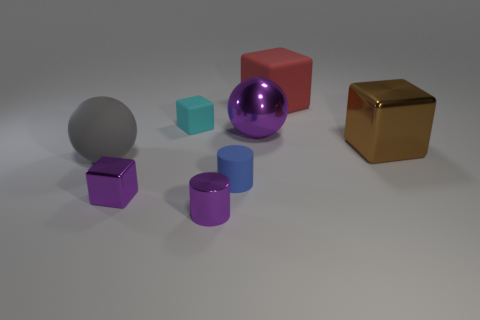Can you tell me about the colors and textures of the objects in the image? Certainly! There's a range of colors and textures here. Starting from the left, we have a gray matte sphere, a violet matte cube, a cyan matte cube, a reflective purple sphere, a deep blue glossy cylinder, and a metallic gold cube. The textures vary from matte to glossy and metallic, providing a contrast both visually and texturally. Which object stands out the most to you? The reflective purple sphere stands out due to its shiny surface that catches the light, creating highlights and reflections that draw the eye. 